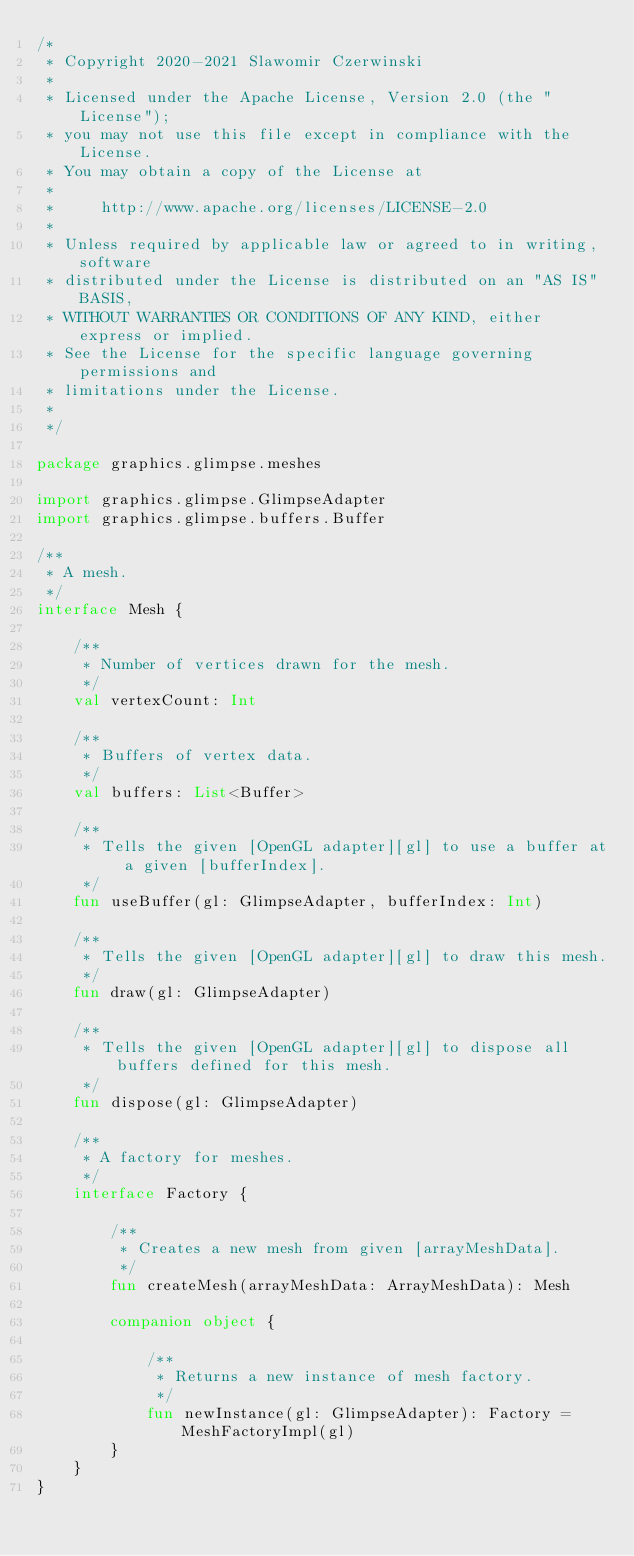Convert code to text. <code><loc_0><loc_0><loc_500><loc_500><_Kotlin_>/*
 * Copyright 2020-2021 Slawomir Czerwinski
 *
 * Licensed under the Apache License, Version 2.0 (the "License");
 * you may not use this file except in compliance with the License.
 * You may obtain a copy of the License at
 *
 *     http://www.apache.org/licenses/LICENSE-2.0
 *
 * Unless required by applicable law or agreed to in writing, software
 * distributed under the License is distributed on an "AS IS" BASIS,
 * WITHOUT WARRANTIES OR CONDITIONS OF ANY KIND, either express or implied.
 * See the License for the specific language governing permissions and
 * limitations under the License.
 *
 */

package graphics.glimpse.meshes

import graphics.glimpse.GlimpseAdapter
import graphics.glimpse.buffers.Buffer

/**
 * A mesh.
 */
interface Mesh {

    /**
     * Number of vertices drawn for the mesh.
     */
    val vertexCount: Int

    /**
     * Buffers of vertex data.
     */
    val buffers: List<Buffer>

    /**
     * Tells the given [OpenGL adapter][gl] to use a buffer at a given [bufferIndex].
     */
    fun useBuffer(gl: GlimpseAdapter, bufferIndex: Int)

    /**
     * Tells the given [OpenGL adapter][gl] to draw this mesh.
     */
    fun draw(gl: GlimpseAdapter)

    /**
     * Tells the given [OpenGL adapter][gl] to dispose all buffers defined for this mesh.
     */
    fun dispose(gl: GlimpseAdapter)

    /**
     * A factory for meshes.
     */
    interface Factory {

        /**
         * Creates a new mesh from given [arrayMeshData].
         */
        fun createMesh(arrayMeshData: ArrayMeshData): Mesh

        companion object {

            /**
             * Returns a new instance of mesh factory.
             */
            fun newInstance(gl: GlimpseAdapter): Factory = MeshFactoryImpl(gl)
        }
    }
}
</code> 